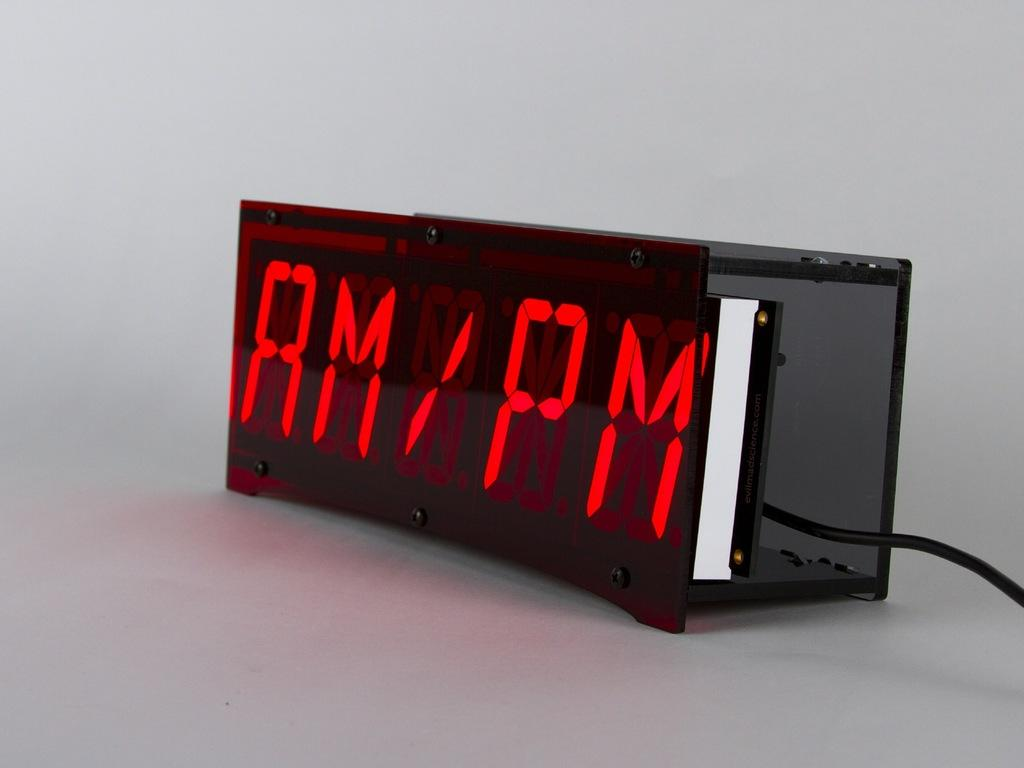<image>
Render a clear and concise summary of the photo. A digital clock displays AM/PM in red lights. 